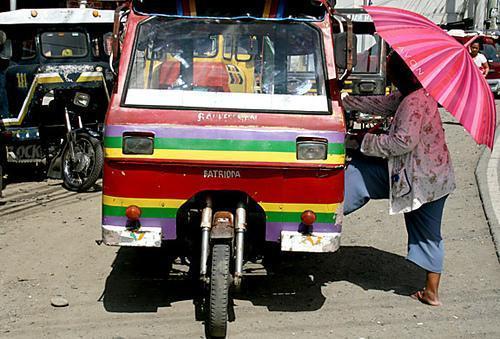How many people can be seen?
Give a very brief answer. 2. How many different color stripes are on this truck?
Give a very brief answer. 4. How many wheels are pictured?
Give a very brief answer. 2. How many kites are in the trees?
Give a very brief answer. 0. 